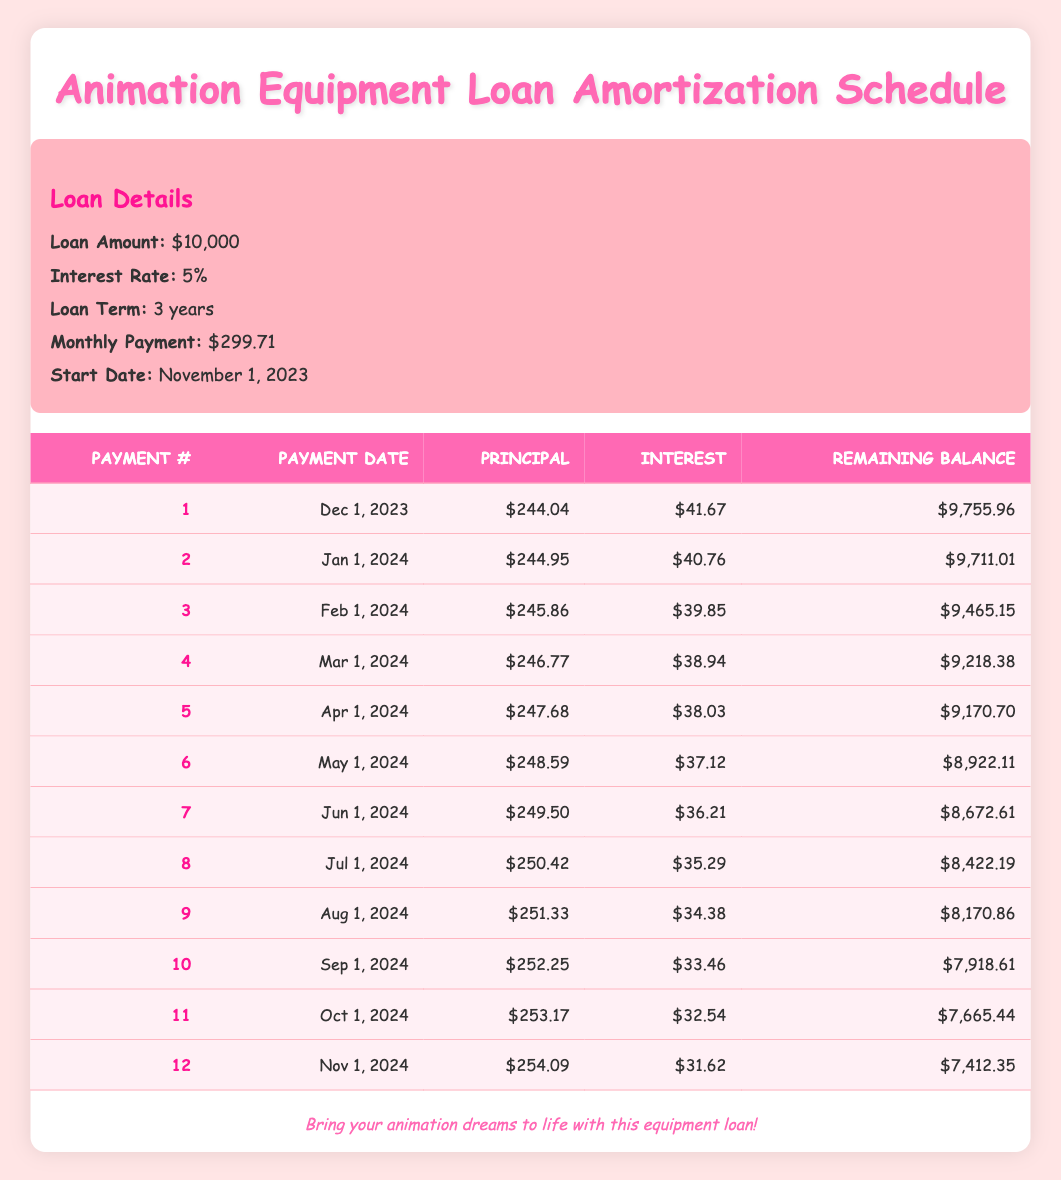What is the total loan amount for the animation equipment? The loan amount stated in the loan details section is $10,000. This is a direct retrieval from the provided information.
Answer: 10,000 What is the monthly payment amount? The monthly payment amount listed in the loan details is $299.71. This can be answered directly from the table's loan information.
Answer: 299.71 How much interest is paid in the first payment? The interest paid in the first payment, according to the amortization schedule for payment number 1, is $41.67. This value is directly provided in the table.
Answer: 41.67 What is the remaining balance after the second payment? After the second payment, the remaining balance listed in the table for payment number 2 is $9,711.01. This is specifically noted in the schedule.
Answer: 9,711.01 What is the sum of the principal payments for the first three months? The principal payments for the first three months are $244.04 (1st) + $244.95 (2nd) + $245.86 (3rd) = $734.85. Therefore, we sum these values to find the total over these payment periods.
Answer: 734.85 Was the principal payment greater than the interest payment in the sixth payment? In the sixth payment, the principal payment is $248.59 and the interest payment is $37.12. Since $248.59 is greater than $37.12, the answer is yes.
Answer: Yes What is the average principal payment of the first twelve payments? To find the average principal payment, we sum all the principal payments: 244.04 + 244.95 + 245.86 + 246.77 + 247.68 + 248.59 + 249.50 + 250.42 + 251.33 + 252.25 + 253.17 + 254.09 = 3,018.49. Then, we divide by 12 to get the average, which is about 251.54.
Answer: 251.54 Is more than $9000 remaining after the first five payments? After the fifth payment, the remaining balance is $9,170.70. Since $9,170.70 is greater than $9,000, the answer is yes.
Answer: Yes How much total interest will be paid in the first year? To determine the total interest paid in the first year, we add the interest payments for the first twelve months: $41.67 + $40.76 + $39.85 + $38.94 + $38.03 + $37.12 + $36.21 + $35.29 + $34.38 + $33.46 + $32.54 + $31.62 = $420.17, thus giving us the total interest paid in the first year as approximately $420.17.
Answer: 420.17 